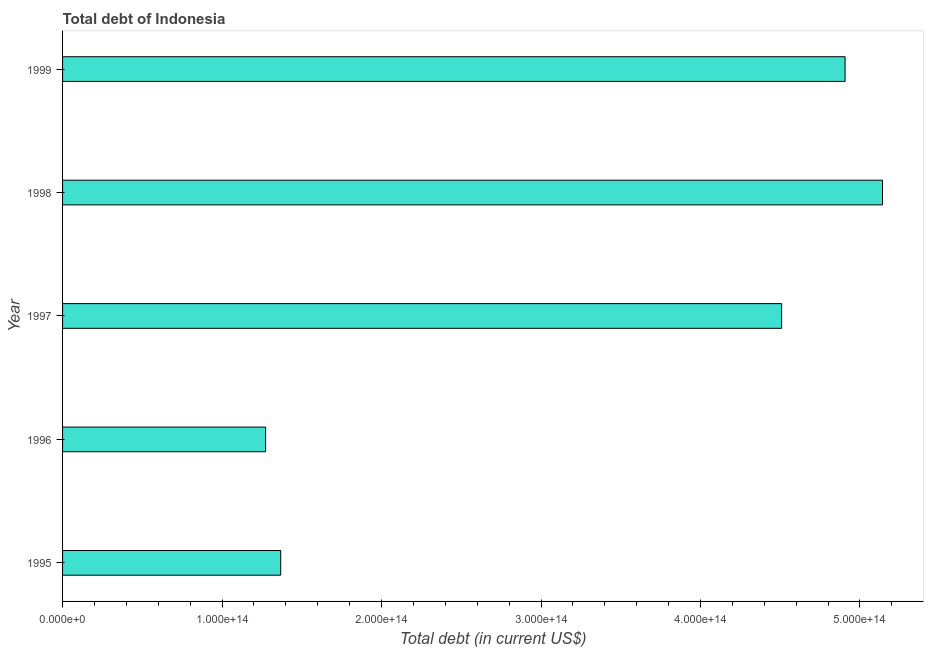Does the graph contain any zero values?
Provide a short and direct response. No. What is the title of the graph?
Your answer should be very brief. Total debt of Indonesia. What is the label or title of the X-axis?
Make the answer very short. Total debt (in current US$). What is the total debt in 1998?
Give a very brief answer. 5.14e+14. Across all years, what is the maximum total debt?
Give a very brief answer. 5.14e+14. Across all years, what is the minimum total debt?
Your answer should be compact. 1.27e+14. In which year was the total debt maximum?
Your response must be concise. 1998. What is the sum of the total debt?
Your answer should be compact. 1.72e+15. What is the difference between the total debt in 1995 and 1999?
Make the answer very short. -3.54e+14. What is the average total debt per year?
Your response must be concise. 3.44e+14. What is the median total debt?
Your answer should be very brief. 4.51e+14. In how many years, is the total debt greater than 480000000000000 US$?
Provide a succinct answer. 2. Do a majority of the years between 1999 and 1998 (inclusive) have total debt greater than 360000000000000 US$?
Offer a very short reply. No. What is the ratio of the total debt in 1996 to that in 1997?
Offer a very short reply. 0.28. Is the total debt in 1995 less than that in 1997?
Ensure brevity in your answer.  Yes. What is the difference between the highest and the second highest total debt?
Make the answer very short. 2.34e+13. Is the sum of the total debt in 1996 and 1997 greater than the maximum total debt across all years?
Your answer should be very brief. Yes. What is the difference between the highest and the lowest total debt?
Give a very brief answer. 3.87e+14. In how many years, is the total debt greater than the average total debt taken over all years?
Offer a terse response. 3. What is the difference between two consecutive major ticks on the X-axis?
Your answer should be very brief. 1.00e+14. What is the Total debt (in current US$) in 1995?
Ensure brevity in your answer.  1.37e+14. What is the Total debt (in current US$) in 1996?
Provide a succinct answer. 1.27e+14. What is the Total debt (in current US$) in 1997?
Your answer should be very brief. 4.51e+14. What is the Total debt (in current US$) of 1998?
Your response must be concise. 5.14e+14. What is the Total debt (in current US$) in 1999?
Offer a terse response. 4.91e+14. What is the difference between the Total debt (in current US$) in 1995 and 1996?
Keep it short and to the point. 9.46e+12. What is the difference between the Total debt (in current US$) in 1995 and 1997?
Provide a succinct answer. -3.14e+14. What is the difference between the Total debt (in current US$) in 1995 and 1998?
Make the answer very short. -3.77e+14. What is the difference between the Total debt (in current US$) in 1995 and 1999?
Give a very brief answer. -3.54e+14. What is the difference between the Total debt (in current US$) in 1996 and 1997?
Provide a succinct answer. -3.24e+14. What is the difference between the Total debt (in current US$) in 1996 and 1998?
Give a very brief answer. -3.87e+14. What is the difference between the Total debt (in current US$) in 1996 and 1999?
Keep it short and to the point. -3.63e+14. What is the difference between the Total debt (in current US$) in 1997 and 1998?
Keep it short and to the point. -6.32e+13. What is the difference between the Total debt (in current US$) in 1997 and 1999?
Offer a terse response. -3.98e+13. What is the difference between the Total debt (in current US$) in 1998 and 1999?
Your response must be concise. 2.34e+13. What is the ratio of the Total debt (in current US$) in 1995 to that in 1996?
Your response must be concise. 1.07. What is the ratio of the Total debt (in current US$) in 1995 to that in 1997?
Offer a terse response. 0.3. What is the ratio of the Total debt (in current US$) in 1995 to that in 1998?
Provide a succinct answer. 0.27. What is the ratio of the Total debt (in current US$) in 1995 to that in 1999?
Make the answer very short. 0.28. What is the ratio of the Total debt (in current US$) in 1996 to that in 1997?
Provide a succinct answer. 0.28. What is the ratio of the Total debt (in current US$) in 1996 to that in 1998?
Make the answer very short. 0.25. What is the ratio of the Total debt (in current US$) in 1996 to that in 1999?
Your response must be concise. 0.26. What is the ratio of the Total debt (in current US$) in 1997 to that in 1998?
Offer a terse response. 0.88. What is the ratio of the Total debt (in current US$) in 1997 to that in 1999?
Offer a terse response. 0.92. What is the ratio of the Total debt (in current US$) in 1998 to that in 1999?
Give a very brief answer. 1.05. 